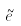<formula> <loc_0><loc_0><loc_500><loc_500>\tilde { e }</formula> 